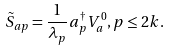Convert formula to latex. <formula><loc_0><loc_0><loc_500><loc_500>\tilde { S } _ { a p } = \frac { 1 } { \lambda _ { p } } a _ { p } ^ { \dagger } V _ { a } ^ { 0 } , p \leq 2 k .</formula> 